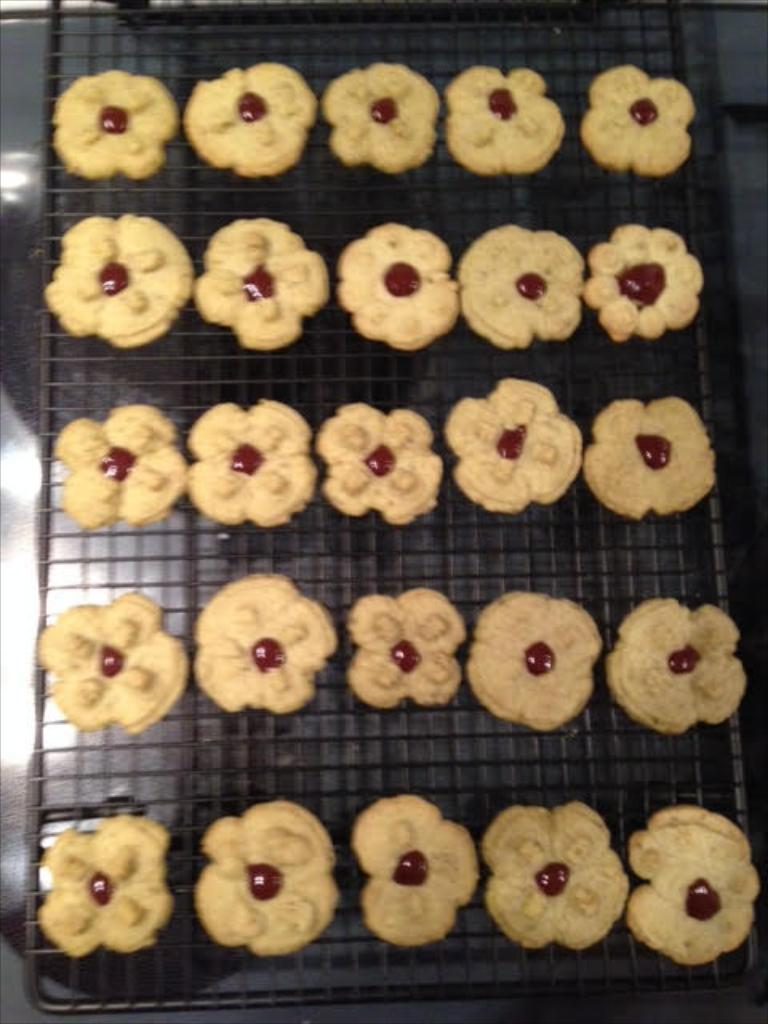What type of food can be seen in the image? There are cookies in the image. Where are the cookies located? The cookies are on a grill. What type of lace is draped over the cookies in the image? There is no lace present in the image; it only features cookies on a grill. 